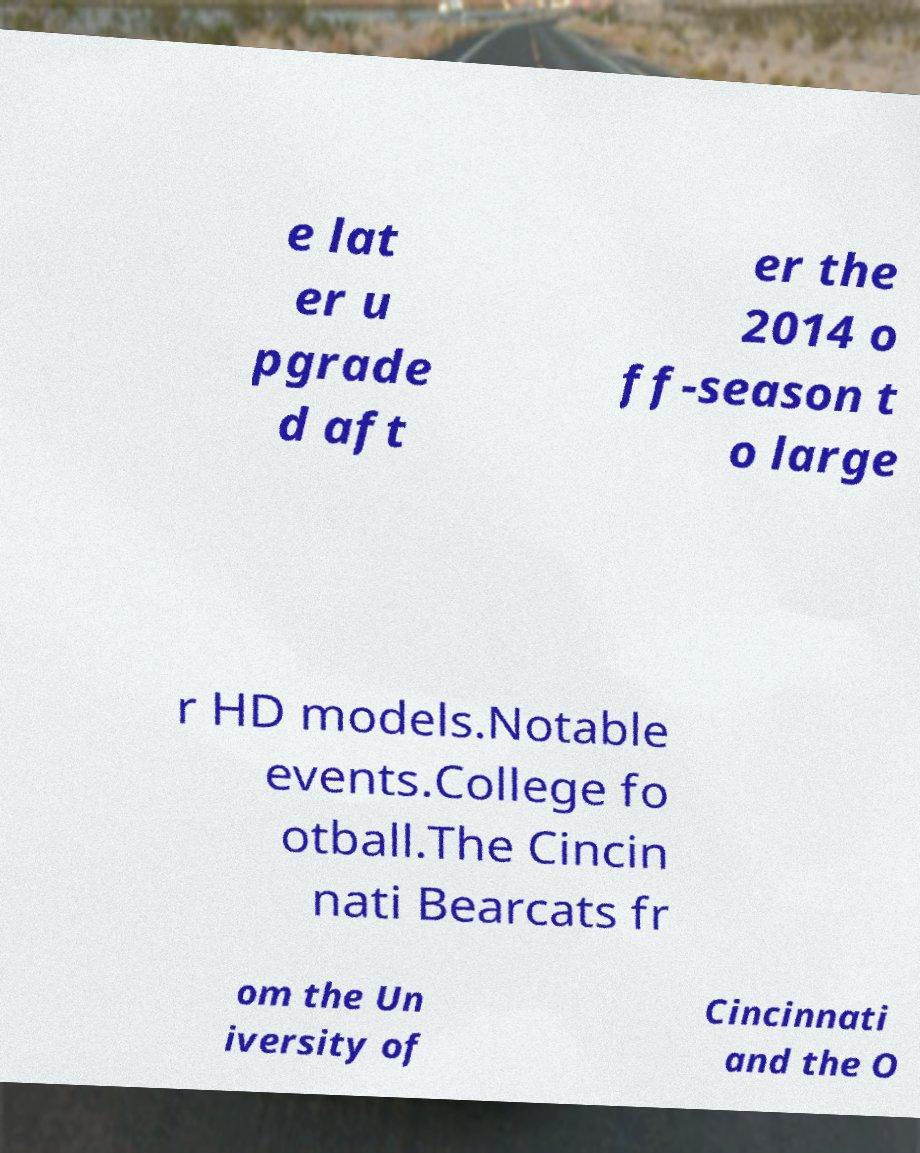There's text embedded in this image that I need extracted. Can you transcribe it verbatim? e lat er u pgrade d aft er the 2014 o ff-season t o large r HD models.Notable events.College fo otball.The Cincin nati Bearcats fr om the Un iversity of Cincinnati and the O 